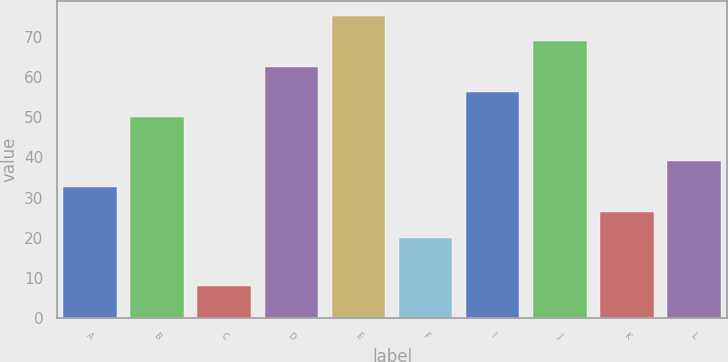Convert chart to OTSL. <chart><loc_0><loc_0><loc_500><loc_500><bar_chart><fcel>A<fcel>B<fcel>C<fcel>D<fcel>E<fcel>F<fcel>I<fcel>J<fcel>K<fcel>L<nl><fcel>32.6<fcel>50<fcel>8<fcel>62.6<fcel>75.2<fcel>20<fcel>56.3<fcel>68.9<fcel>26.3<fcel>39<nl></chart> 